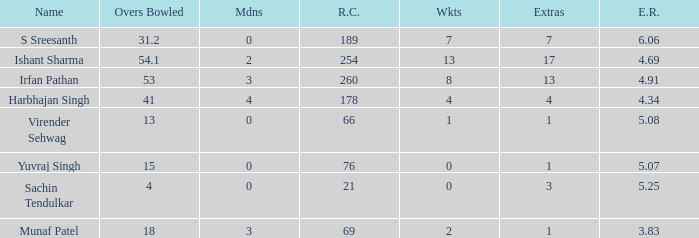Name the maaidens where overs bowled is 13 0.0. 